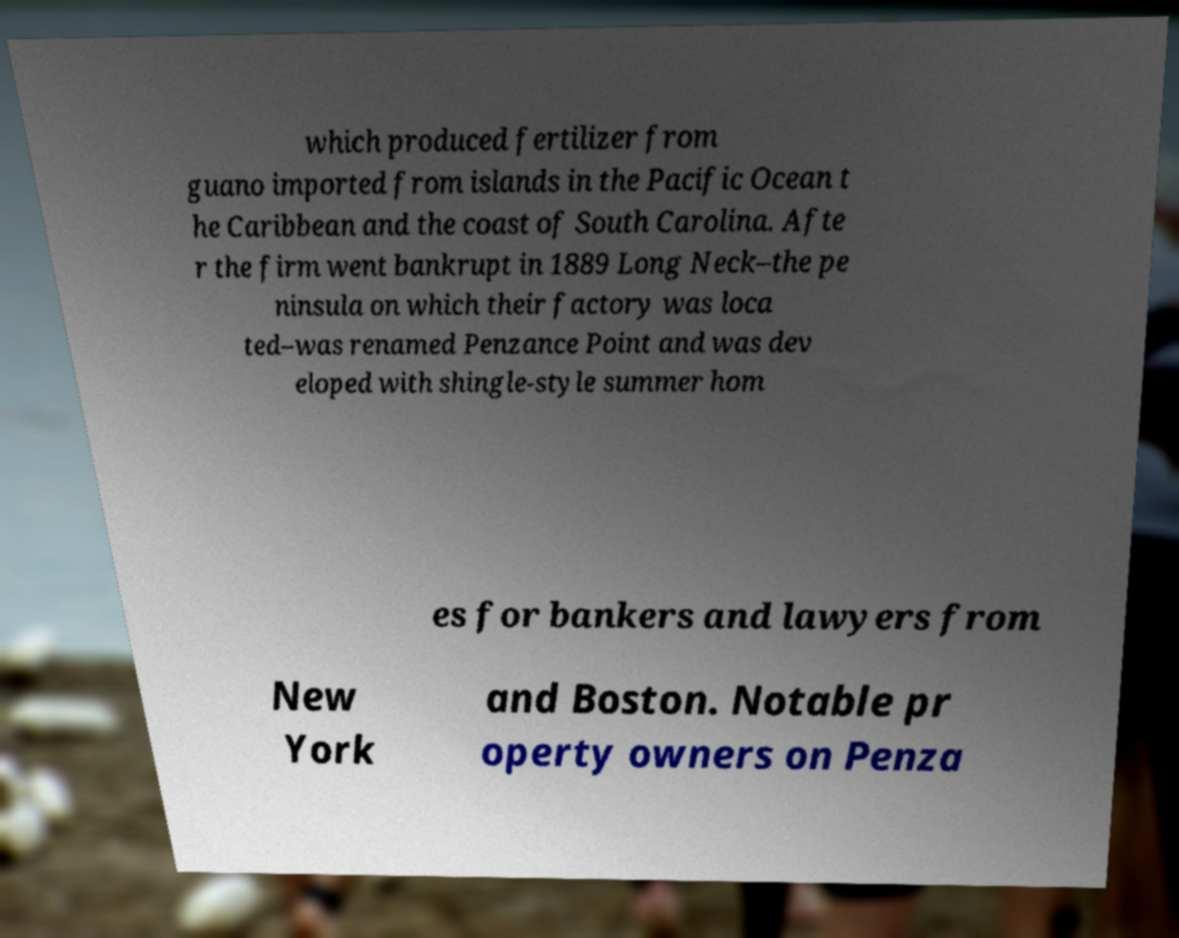There's text embedded in this image that I need extracted. Can you transcribe it verbatim? which produced fertilizer from guano imported from islands in the Pacific Ocean t he Caribbean and the coast of South Carolina. Afte r the firm went bankrupt in 1889 Long Neck–the pe ninsula on which their factory was loca ted–was renamed Penzance Point and was dev eloped with shingle-style summer hom es for bankers and lawyers from New York and Boston. Notable pr operty owners on Penza 